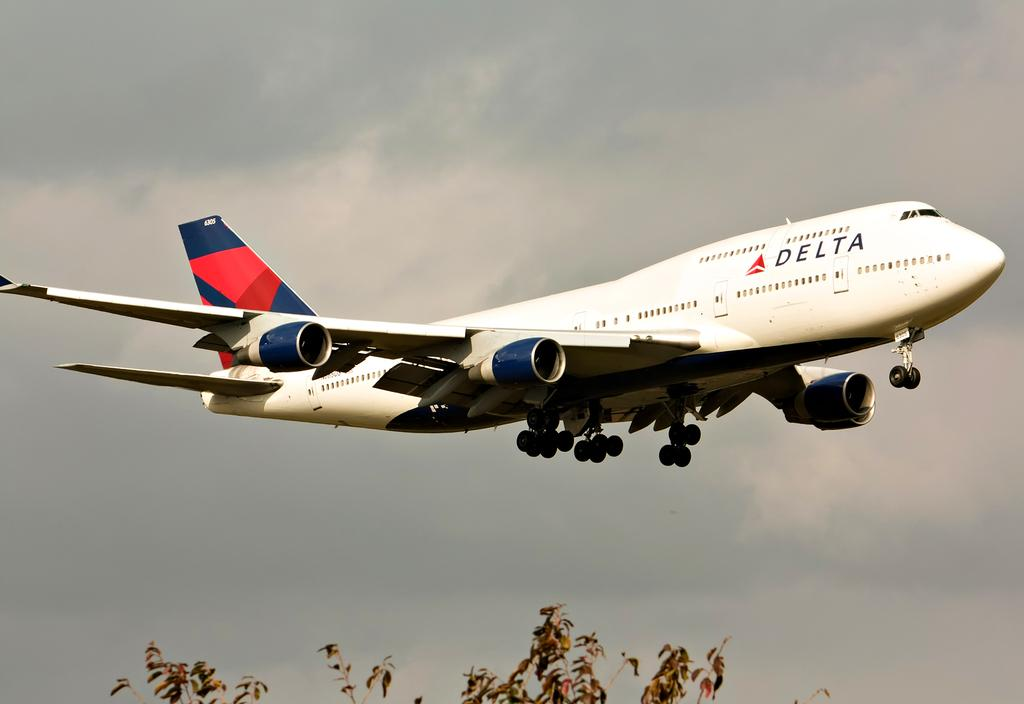What is the main subject of the image? The main subject of the image is an aircraft. What colors can be seen on the aircraft? The aircraft is white, blue, and red in color. What is the aircraft doing in the image? The aircraft is flying in the air. What type of vegetation is visible in the image? There is a tree visible in the image. What is visible in the background of the image? The sky is visible in the background of the image. How many chickens are standing on the wing of the aircraft in the image? There are no chickens present on the wing of the aircraft in the image. What type of sorting method is being used by the aircraft in the image? The image does not depict any sorting method being used by the aircraft. 